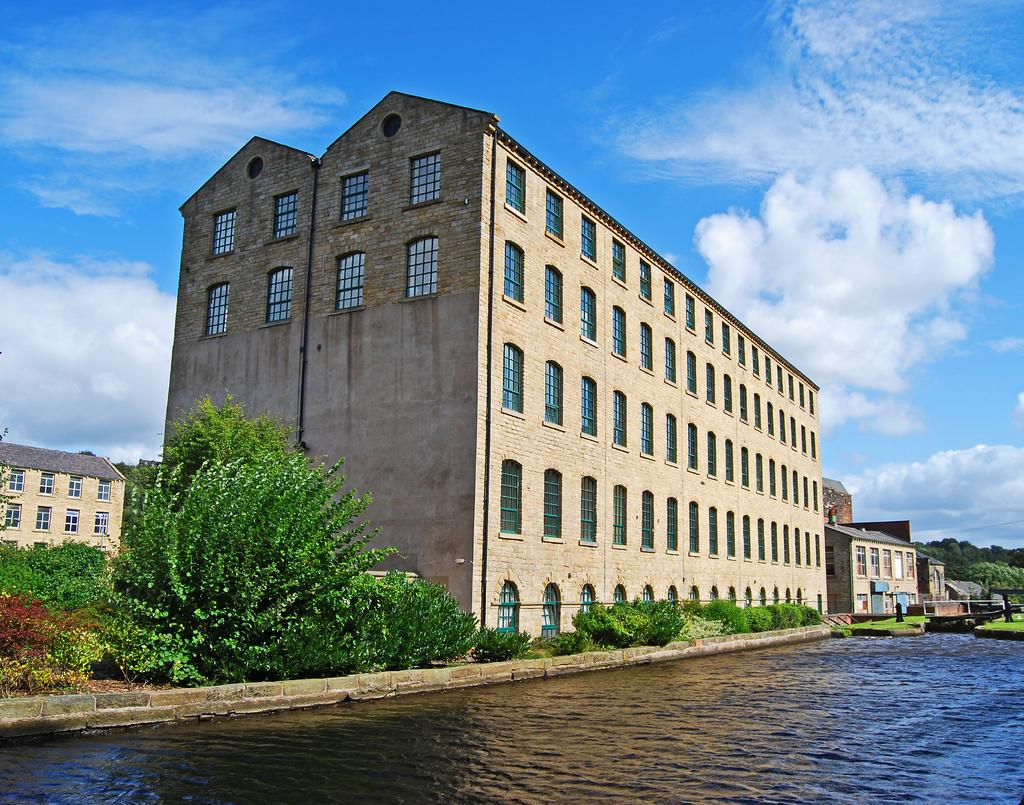What is in the foreground of the image? There is a water surface in the foreground of the image. What else can be seen in the image besides the water surface? There are plants and buildings visible in the image. Where are the trees located in the image? The trees are present on the right side of the image, beside the buildings. How many flowers can be seen growing on the trees in the image? There are no flowers visible on the trees in the image; only trees and buildings are present. 